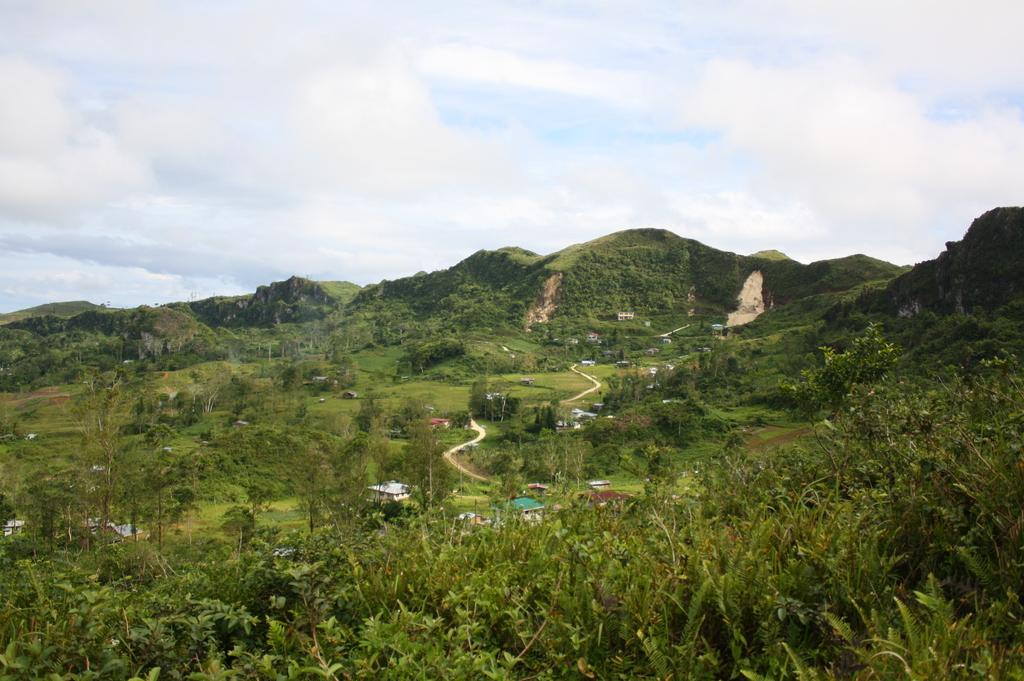What is located at the front of the image? There are many plants in the front of the image. What can be seen in the middle of the image? There are buildings in the middle of the image. What is visible in the background of the image? There are hills covered with trees in the background of the image. What is visible above the buildings and plants? The sky is visible in the image. What can be observed in the sky? Clouds are present in the sky. How many cakes are placed on the hills in the image? There are no cakes present on the hills in the image; they are covered with trees. What type of ocean can be seen in the background of the image? There is no ocean visible in the image; it features hills covered with trees in the background. 